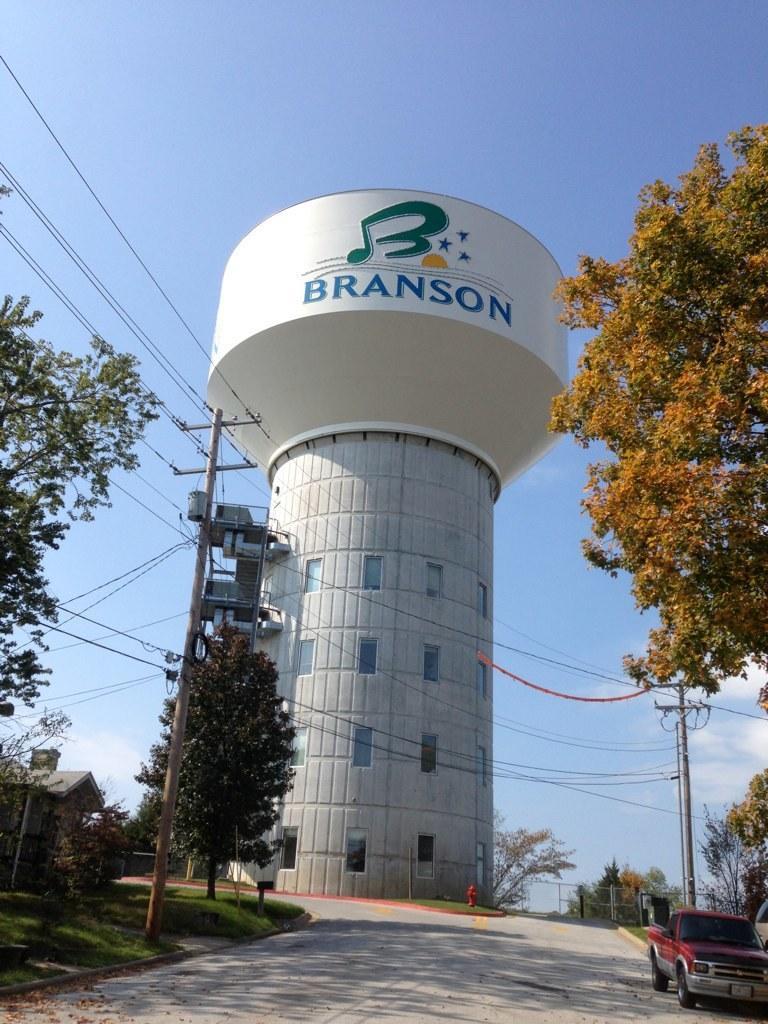Could you give a brief overview of what you see in this image? In the foreground of this image, there is a road and on either side, there are trees, poles, cables and the grass. On the right, there is a car on the road. On the left, it seems like a tank, few trees and the sky. 